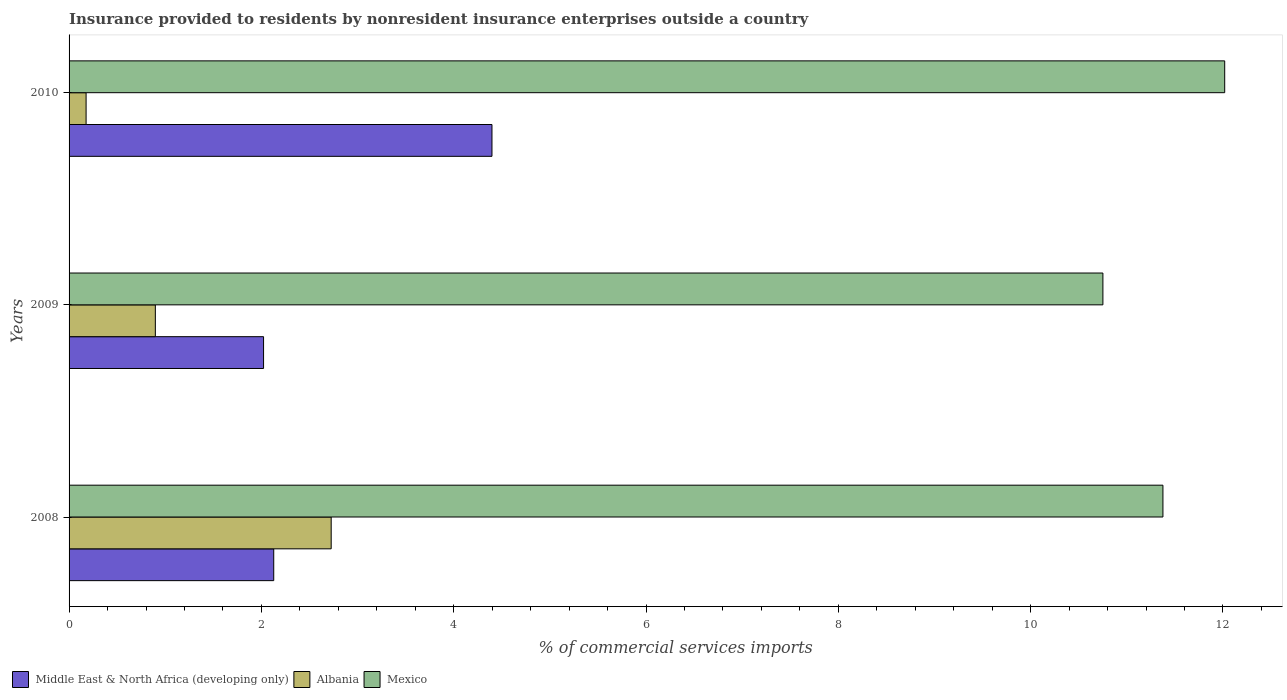How many different coloured bars are there?
Give a very brief answer. 3. How many bars are there on the 1st tick from the bottom?
Your answer should be compact. 3. In how many cases, is the number of bars for a given year not equal to the number of legend labels?
Your answer should be very brief. 0. What is the Insurance provided to residents in Mexico in 2009?
Your answer should be very brief. 10.75. Across all years, what is the maximum Insurance provided to residents in Middle East & North Africa (developing only)?
Provide a short and direct response. 4.4. Across all years, what is the minimum Insurance provided to residents in Albania?
Provide a short and direct response. 0.18. In which year was the Insurance provided to residents in Albania minimum?
Provide a short and direct response. 2010. What is the total Insurance provided to residents in Middle East & North Africa (developing only) in the graph?
Your answer should be compact. 8.55. What is the difference between the Insurance provided to residents in Mexico in 2009 and that in 2010?
Provide a succinct answer. -1.27. What is the difference between the Insurance provided to residents in Mexico in 2009 and the Insurance provided to residents in Albania in 2008?
Provide a succinct answer. 8.03. What is the average Insurance provided to residents in Middle East & North Africa (developing only) per year?
Your answer should be very brief. 2.85. In the year 2008, what is the difference between the Insurance provided to residents in Mexico and Insurance provided to residents in Middle East & North Africa (developing only)?
Provide a short and direct response. 9.25. What is the ratio of the Insurance provided to residents in Mexico in 2009 to that in 2010?
Offer a very short reply. 0.89. Is the Insurance provided to residents in Middle East & North Africa (developing only) in 2009 less than that in 2010?
Give a very brief answer. Yes. What is the difference between the highest and the second highest Insurance provided to residents in Albania?
Your answer should be very brief. 1.83. What is the difference between the highest and the lowest Insurance provided to residents in Mexico?
Make the answer very short. 1.27. In how many years, is the Insurance provided to residents in Albania greater than the average Insurance provided to residents in Albania taken over all years?
Offer a very short reply. 1. Are the values on the major ticks of X-axis written in scientific E-notation?
Give a very brief answer. No. Does the graph contain any zero values?
Offer a very short reply. No. What is the title of the graph?
Your answer should be very brief. Insurance provided to residents by nonresident insurance enterprises outside a country. Does "Rwanda" appear as one of the legend labels in the graph?
Your response must be concise. No. What is the label or title of the X-axis?
Give a very brief answer. % of commercial services imports. What is the % of commercial services imports in Middle East & North Africa (developing only) in 2008?
Make the answer very short. 2.13. What is the % of commercial services imports in Albania in 2008?
Provide a short and direct response. 2.73. What is the % of commercial services imports of Mexico in 2008?
Offer a terse response. 11.38. What is the % of commercial services imports of Middle East & North Africa (developing only) in 2009?
Your answer should be very brief. 2.02. What is the % of commercial services imports in Albania in 2009?
Keep it short and to the point. 0.9. What is the % of commercial services imports of Mexico in 2009?
Keep it short and to the point. 10.75. What is the % of commercial services imports of Middle East & North Africa (developing only) in 2010?
Offer a terse response. 4.4. What is the % of commercial services imports of Albania in 2010?
Keep it short and to the point. 0.18. What is the % of commercial services imports of Mexico in 2010?
Make the answer very short. 12.02. Across all years, what is the maximum % of commercial services imports of Middle East & North Africa (developing only)?
Offer a terse response. 4.4. Across all years, what is the maximum % of commercial services imports of Albania?
Provide a short and direct response. 2.73. Across all years, what is the maximum % of commercial services imports in Mexico?
Make the answer very short. 12.02. Across all years, what is the minimum % of commercial services imports in Middle East & North Africa (developing only)?
Provide a short and direct response. 2.02. Across all years, what is the minimum % of commercial services imports of Albania?
Your response must be concise. 0.18. Across all years, what is the minimum % of commercial services imports in Mexico?
Give a very brief answer. 10.75. What is the total % of commercial services imports in Middle East & North Africa (developing only) in the graph?
Make the answer very short. 8.55. What is the total % of commercial services imports of Albania in the graph?
Provide a succinct answer. 3.8. What is the total % of commercial services imports of Mexico in the graph?
Offer a terse response. 34.15. What is the difference between the % of commercial services imports of Middle East & North Africa (developing only) in 2008 and that in 2009?
Your answer should be very brief. 0.11. What is the difference between the % of commercial services imports in Albania in 2008 and that in 2009?
Provide a short and direct response. 1.83. What is the difference between the % of commercial services imports of Mexico in 2008 and that in 2009?
Ensure brevity in your answer.  0.62. What is the difference between the % of commercial services imports of Middle East & North Africa (developing only) in 2008 and that in 2010?
Provide a succinct answer. -2.27. What is the difference between the % of commercial services imports in Albania in 2008 and that in 2010?
Your response must be concise. 2.55. What is the difference between the % of commercial services imports of Mexico in 2008 and that in 2010?
Provide a short and direct response. -0.64. What is the difference between the % of commercial services imports in Middle East & North Africa (developing only) in 2009 and that in 2010?
Your answer should be very brief. -2.38. What is the difference between the % of commercial services imports of Albania in 2009 and that in 2010?
Your answer should be very brief. 0.72. What is the difference between the % of commercial services imports of Mexico in 2009 and that in 2010?
Offer a terse response. -1.27. What is the difference between the % of commercial services imports of Middle East & North Africa (developing only) in 2008 and the % of commercial services imports of Albania in 2009?
Provide a succinct answer. 1.23. What is the difference between the % of commercial services imports in Middle East & North Africa (developing only) in 2008 and the % of commercial services imports in Mexico in 2009?
Ensure brevity in your answer.  -8.62. What is the difference between the % of commercial services imports in Albania in 2008 and the % of commercial services imports in Mexico in 2009?
Offer a terse response. -8.03. What is the difference between the % of commercial services imports of Middle East & North Africa (developing only) in 2008 and the % of commercial services imports of Albania in 2010?
Make the answer very short. 1.95. What is the difference between the % of commercial services imports of Middle East & North Africa (developing only) in 2008 and the % of commercial services imports of Mexico in 2010?
Keep it short and to the point. -9.89. What is the difference between the % of commercial services imports in Albania in 2008 and the % of commercial services imports in Mexico in 2010?
Ensure brevity in your answer.  -9.29. What is the difference between the % of commercial services imports in Middle East & North Africa (developing only) in 2009 and the % of commercial services imports in Albania in 2010?
Your answer should be very brief. 1.85. What is the difference between the % of commercial services imports in Middle East & North Africa (developing only) in 2009 and the % of commercial services imports in Mexico in 2010?
Offer a terse response. -10. What is the difference between the % of commercial services imports of Albania in 2009 and the % of commercial services imports of Mexico in 2010?
Offer a terse response. -11.12. What is the average % of commercial services imports in Middle East & North Africa (developing only) per year?
Keep it short and to the point. 2.85. What is the average % of commercial services imports of Albania per year?
Offer a terse response. 1.27. What is the average % of commercial services imports of Mexico per year?
Your answer should be compact. 11.38. In the year 2008, what is the difference between the % of commercial services imports of Middle East & North Africa (developing only) and % of commercial services imports of Albania?
Keep it short and to the point. -0.6. In the year 2008, what is the difference between the % of commercial services imports in Middle East & North Africa (developing only) and % of commercial services imports in Mexico?
Offer a terse response. -9.25. In the year 2008, what is the difference between the % of commercial services imports in Albania and % of commercial services imports in Mexico?
Offer a very short reply. -8.65. In the year 2009, what is the difference between the % of commercial services imports in Middle East & North Africa (developing only) and % of commercial services imports in Albania?
Make the answer very short. 1.13. In the year 2009, what is the difference between the % of commercial services imports in Middle East & North Africa (developing only) and % of commercial services imports in Mexico?
Keep it short and to the point. -8.73. In the year 2009, what is the difference between the % of commercial services imports of Albania and % of commercial services imports of Mexico?
Make the answer very short. -9.85. In the year 2010, what is the difference between the % of commercial services imports of Middle East & North Africa (developing only) and % of commercial services imports of Albania?
Your response must be concise. 4.22. In the year 2010, what is the difference between the % of commercial services imports of Middle East & North Africa (developing only) and % of commercial services imports of Mexico?
Offer a very short reply. -7.62. In the year 2010, what is the difference between the % of commercial services imports in Albania and % of commercial services imports in Mexico?
Offer a terse response. -11.84. What is the ratio of the % of commercial services imports of Middle East & North Africa (developing only) in 2008 to that in 2009?
Provide a short and direct response. 1.05. What is the ratio of the % of commercial services imports of Albania in 2008 to that in 2009?
Provide a short and direct response. 3.04. What is the ratio of the % of commercial services imports in Mexico in 2008 to that in 2009?
Ensure brevity in your answer.  1.06. What is the ratio of the % of commercial services imports in Middle East & North Africa (developing only) in 2008 to that in 2010?
Make the answer very short. 0.48. What is the ratio of the % of commercial services imports of Albania in 2008 to that in 2010?
Provide a succinct answer. 15.39. What is the ratio of the % of commercial services imports of Mexico in 2008 to that in 2010?
Provide a succinct answer. 0.95. What is the ratio of the % of commercial services imports in Middle East & North Africa (developing only) in 2009 to that in 2010?
Keep it short and to the point. 0.46. What is the ratio of the % of commercial services imports in Albania in 2009 to that in 2010?
Your answer should be compact. 5.07. What is the ratio of the % of commercial services imports in Mexico in 2009 to that in 2010?
Your answer should be compact. 0.89. What is the difference between the highest and the second highest % of commercial services imports in Middle East & North Africa (developing only)?
Your answer should be very brief. 2.27. What is the difference between the highest and the second highest % of commercial services imports of Albania?
Ensure brevity in your answer.  1.83. What is the difference between the highest and the second highest % of commercial services imports in Mexico?
Provide a succinct answer. 0.64. What is the difference between the highest and the lowest % of commercial services imports of Middle East & North Africa (developing only)?
Give a very brief answer. 2.38. What is the difference between the highest and the lowest % of commercial services imports of Albania?
Offer a very short reply. 2.55. What is the difference between the highest and the lowest % of commercial services imports in Mexico?
Keep it short and to the point. 1.27. 